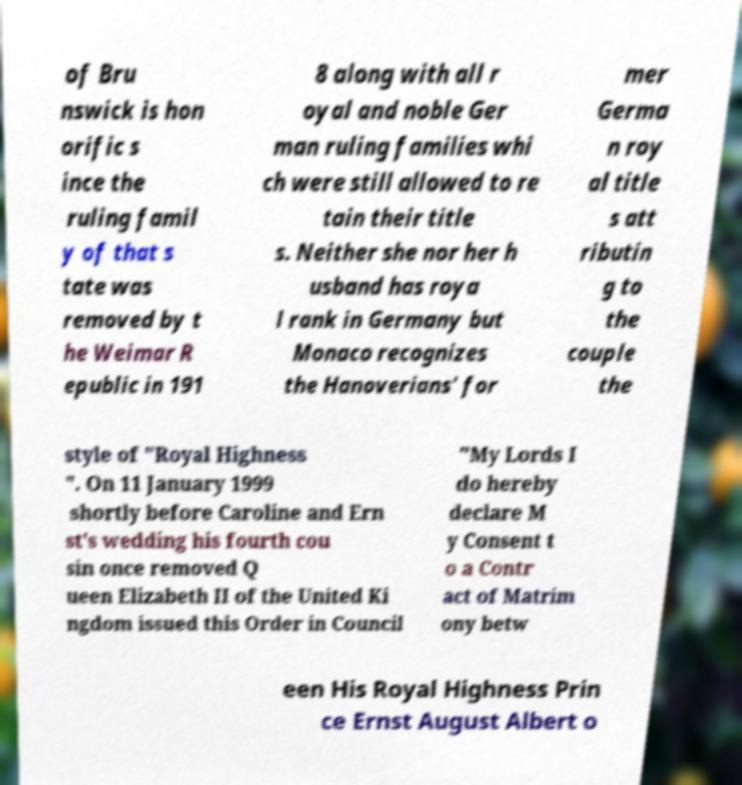Can you read and provide the text displayed in the image?This photo seems to have some interesting text. Can you extract and type it out for me? of Bru nswick is hon orific s ince the ruling famil y of that s tate was removed by t he Weimar R epublic in 191 8 along with all r oyal and noble Ger man ruling families whi ch were still allowed to re tain their title s. Neither she nor her h usband has roya l rank in Germany but Monaco recognizes the Hanoverians' for mer Germa n roy al title s att ributin g to the couple the style of "Royal Highness ". On 11 January 1999 shortly before Caroline and Ern st's wedding his fourth cou sin once removed Q ueen Elizabeth II of the United Ki ngdom issued this Order in Council "My Lords I do hereby declare M y Consent t o a Contr act of Matrim ony betw een His Royal Highness Prin ce Ernst August Albert o 